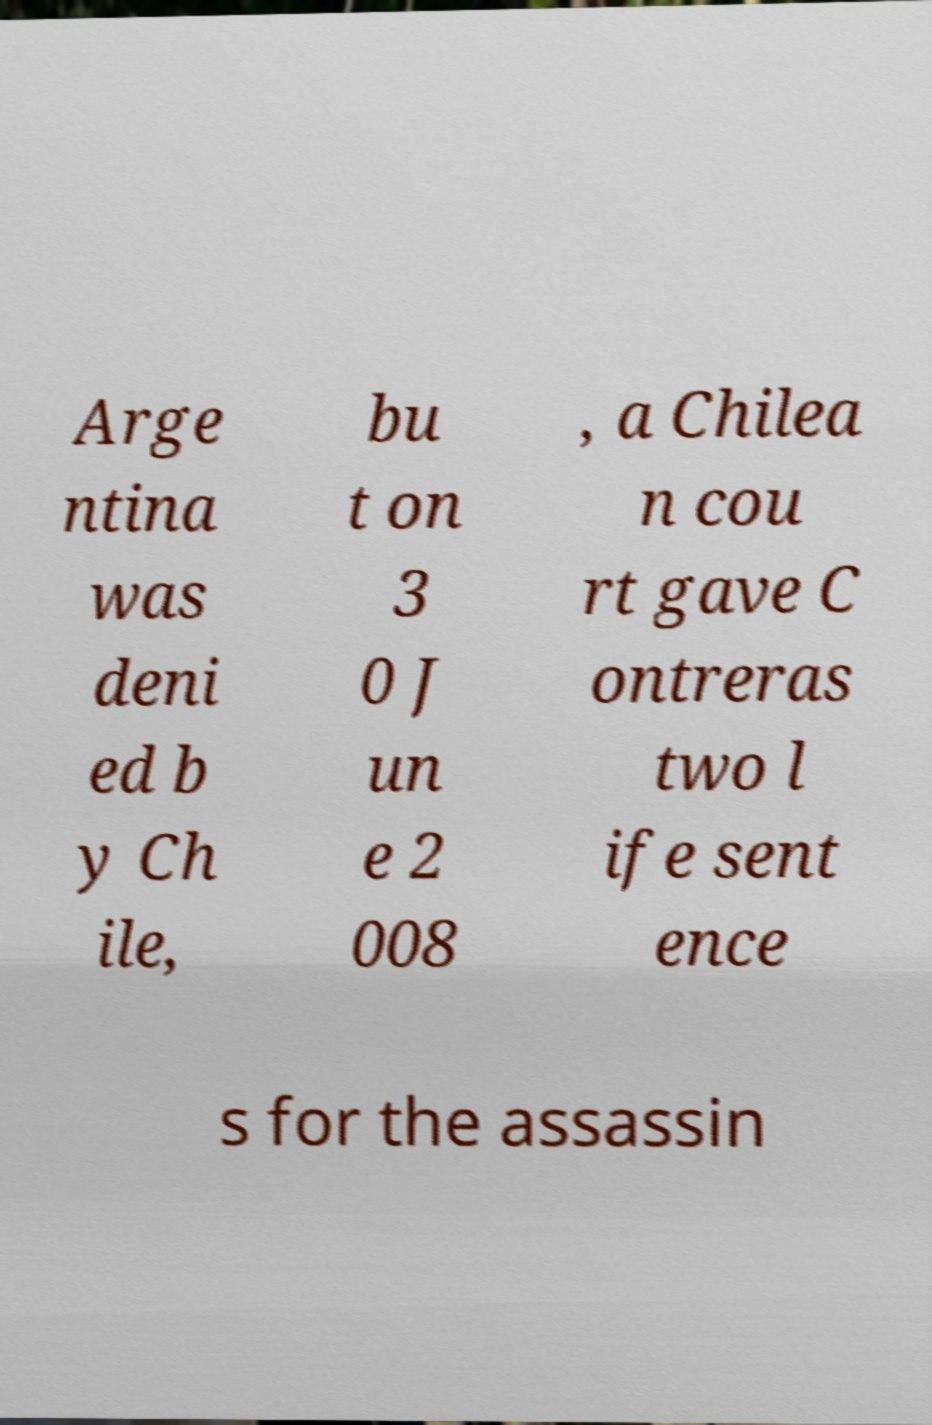What messages or text are displayed in this image? I need them in a readable, typed format. Arge ntina was deni ed b y Ch ile, bu t on 3 0 J un e 2 008 , a Chilea n cou rt gave C ontreras two l ife sent ence s for the assassin 